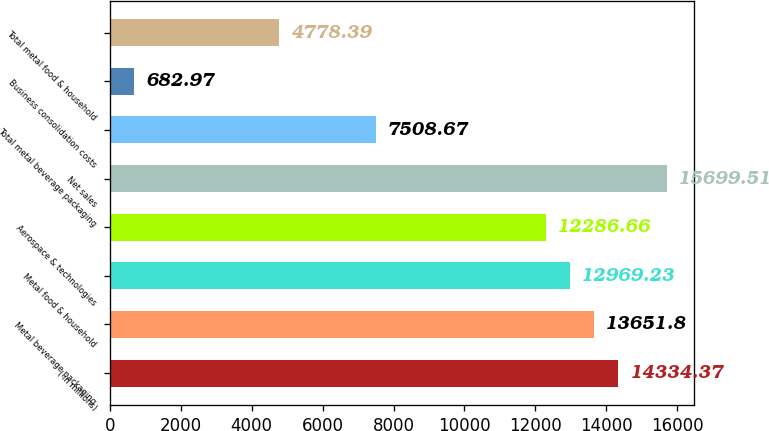Convert chart to OTSL. <chart><loc_0><loc_0><loc_500><loc_500><bar_chart><fcel>( in millions)<fcel>Metal beverage packaging<fcel>Metal food & household<fcel>Aerospace & technologies<fcel>Net sales<fcel>Total metal beverage packaging<fcel>Business consolidation costs<fcel>Total metal food & household<nl><fcel>14334.4<fcel>13651.8<fcel>12969.2<fcel>12286.7<fcel>15699.5<fcel>7508.67<fcel>682.97<fcel>4778.39<nl></chart> 